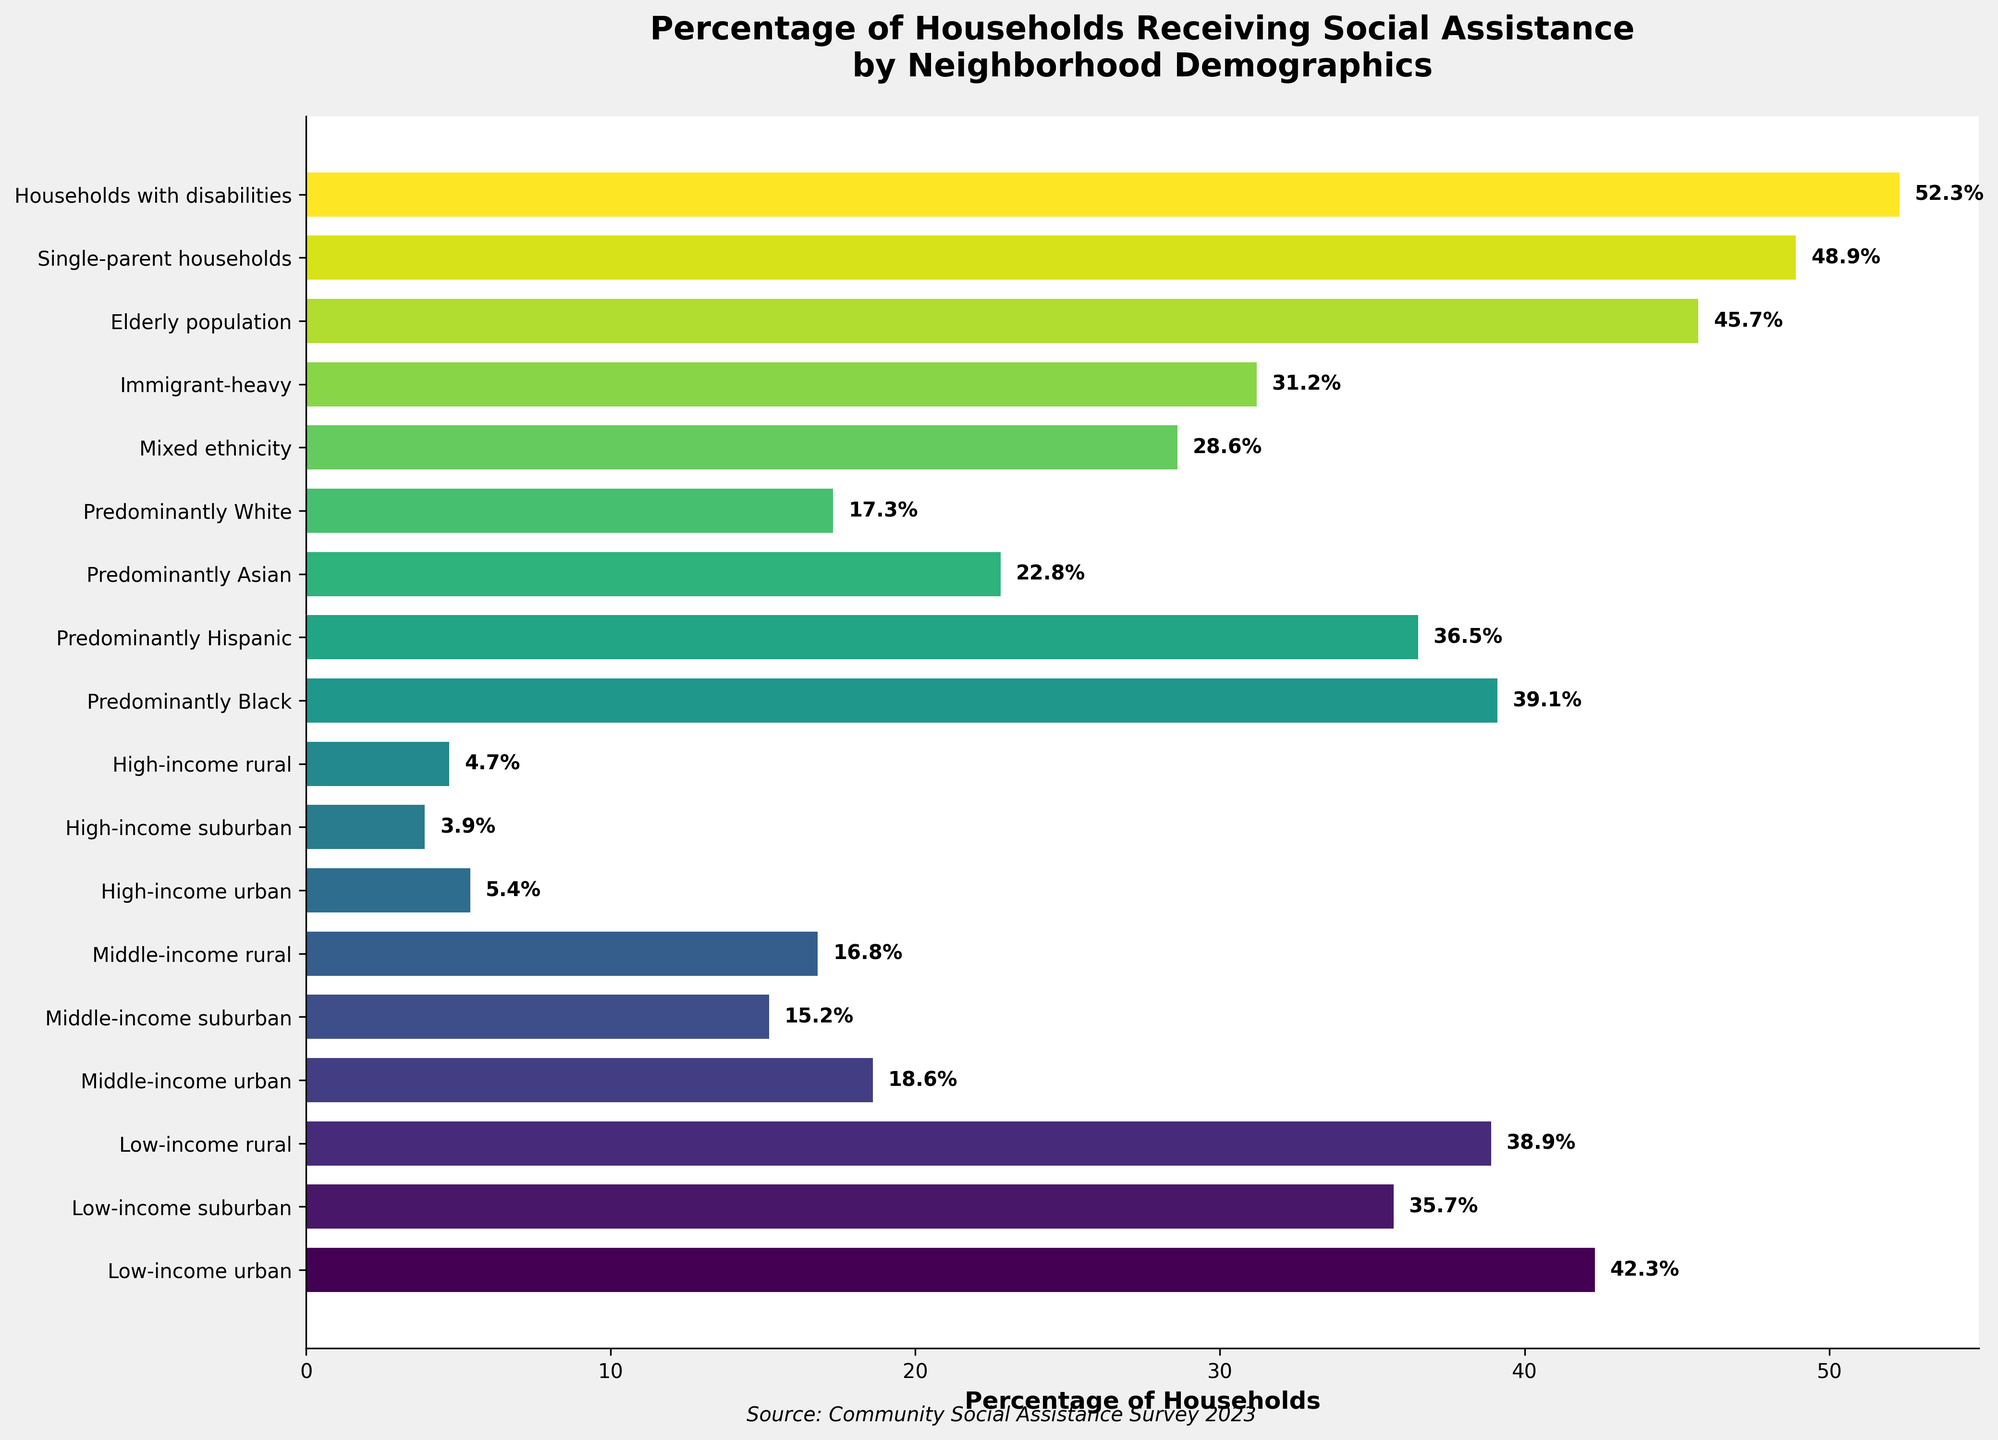What is the percentage of households receiving social assistance in predominantly Black neighborhoods? Locate the bar corresponding to "Predominantly Black" and read the percentage value on it.
Answer: 39.1% Which neighborhood type has the highest percentage of households receiving social assistance? Identify the bar with the longest length/highest value.
Answer: Households with disabilities What is the difference in the percentage of households receiving social assistance between low-income urban and middle-income suburban neighborhoods? Subtract the percentage of middle-income suburban (15.2) from low-income urban (42.3).
Answer: 27.1% What is the average percentage of households receiving social assistance in neighborhoods classified as low-income? Add the percentages of low-income urban (42.3), low-income suburban (35.7), and low-income rural (38.9) and divide by 3. (42.3 + 35.7 + 38.9) / 3 = 116.9 / 3 = 39.0
Answer: 39.0% Which neighborhood has a higher percentage of households receiving social assistance: predominantly Hispanic or predominantly Asian? Compare the percentages of predominantly Hispanic (36.5) and predominantly Asian (22.8) neighborhoods.
Answer: Predominantly Hispanic By how much does the percentage of households receiving social assistance in single-parent households exceed that of high-income rural neighborhoods? Subtract the percentage of high-income rural (4.7) from single-parent households (48.9).
Answer: 44.2% What is the median percentage of households receiving social assistance across all neighborhoods? Order all percentages and find the middle value. Ordered percentages: 3.9, 4.7, 5.4, 15.2, 16.8, 17.3, 18.6, 22.8, 28.6, 31.2, 35.7, 36.5, 38.9, 39.1, 42.3, 45.7, 48.9, 52.3. Median is at the 9th and 10th values (35.7+36.5)/2.
Answer: 36.1% How does the percentage of households receiving social assistance in immigrant-heavy neighborhoods compare to middle-income urban neighborhoods? Compare the percentages of immigrant-heavy (31.2) to middle-income urban (18.6).
Answer: Higher Which neighborhood with a predominantly single demographic has the highest percentage of households receiving social assistance: elderly population, single-parent households, or households with disabilities? Compare the percentages of elderly population (45.7), single-parent households (48.9), and households with disabilities (52.3).
Answer: Households with disabilities What is the sum of the percentages for predominantly Hispanic and immigrant-heavy neighborhoods? Add the percentages of predominantly Hispanic (36.5) and immigrant-heavy (31.2).
Answer: 67.7% 